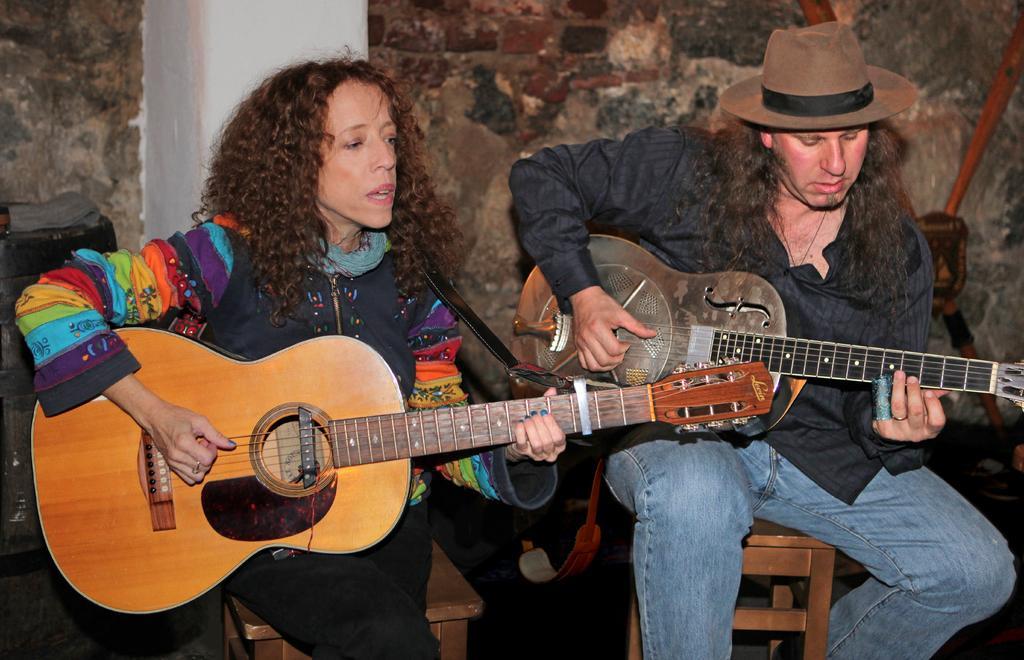Please provide a concise description of this image. In this image I can see two people are playing the musical instruments. 